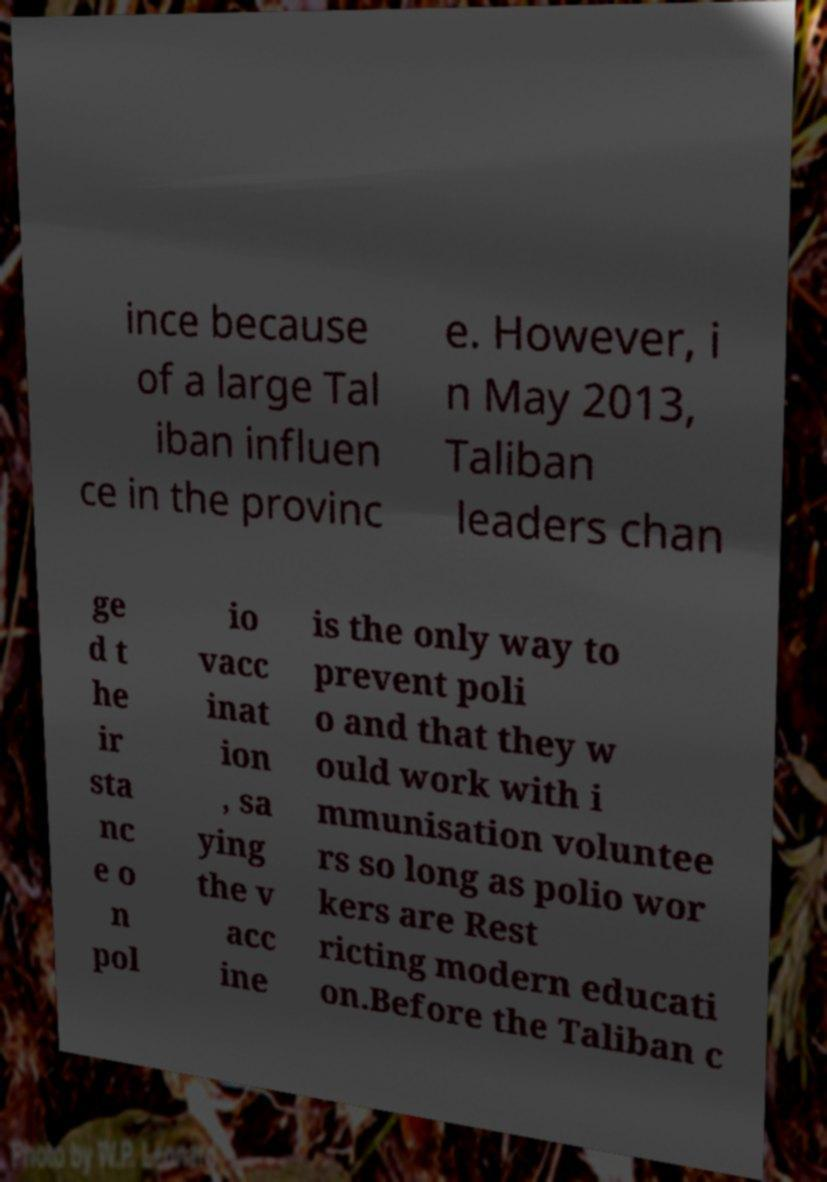What messages or text are displayed in this image? I need them in a readable, typed format. ince because of a large Tal iban influen ce in the provinc e. However, i n May 2013, Taliban leaders chan ge d t he ir sta nc e o n pol io vacc inat ion , sa ying the v acc ine is the only way to prevent poli o and that they w ould work with i mmunisation voluntee rs so long as polio wor kers are Rest ricting modern educati on.Before the Taliban c 